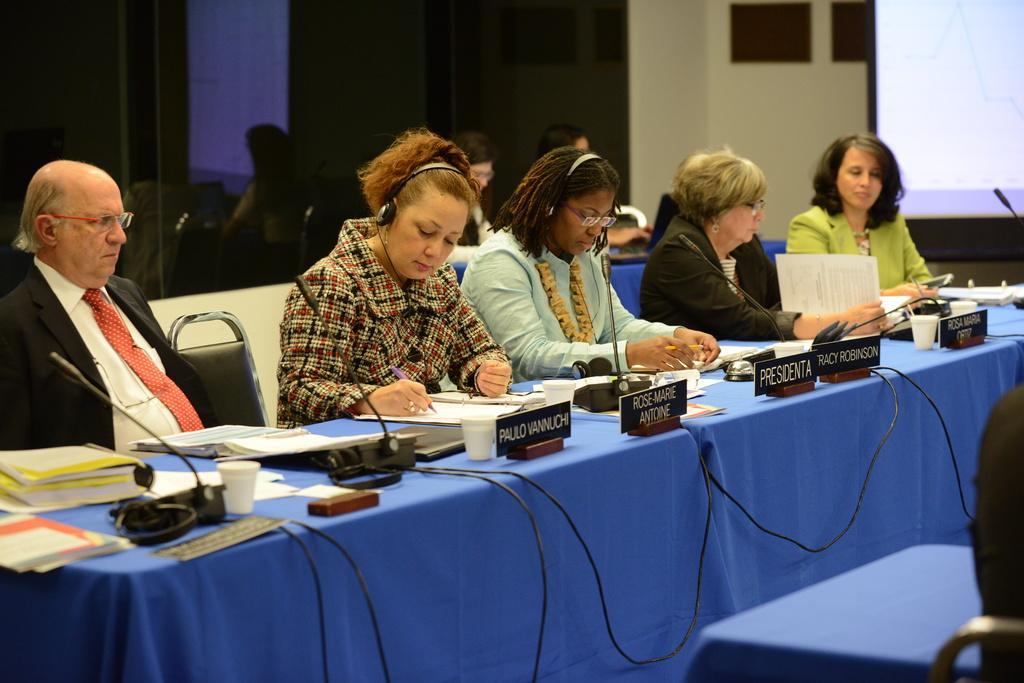Describe this image in one or two sentences. In this image we can see a few people sitting on the chairs in front of the table and the table is covered with a blue color cloth. On the table we can see the books, mike's with wires, cups, papers and also name boards. In the background we can see the screen for displaying. We can also see the frames attached to a wall. There is also a woman sitting. 